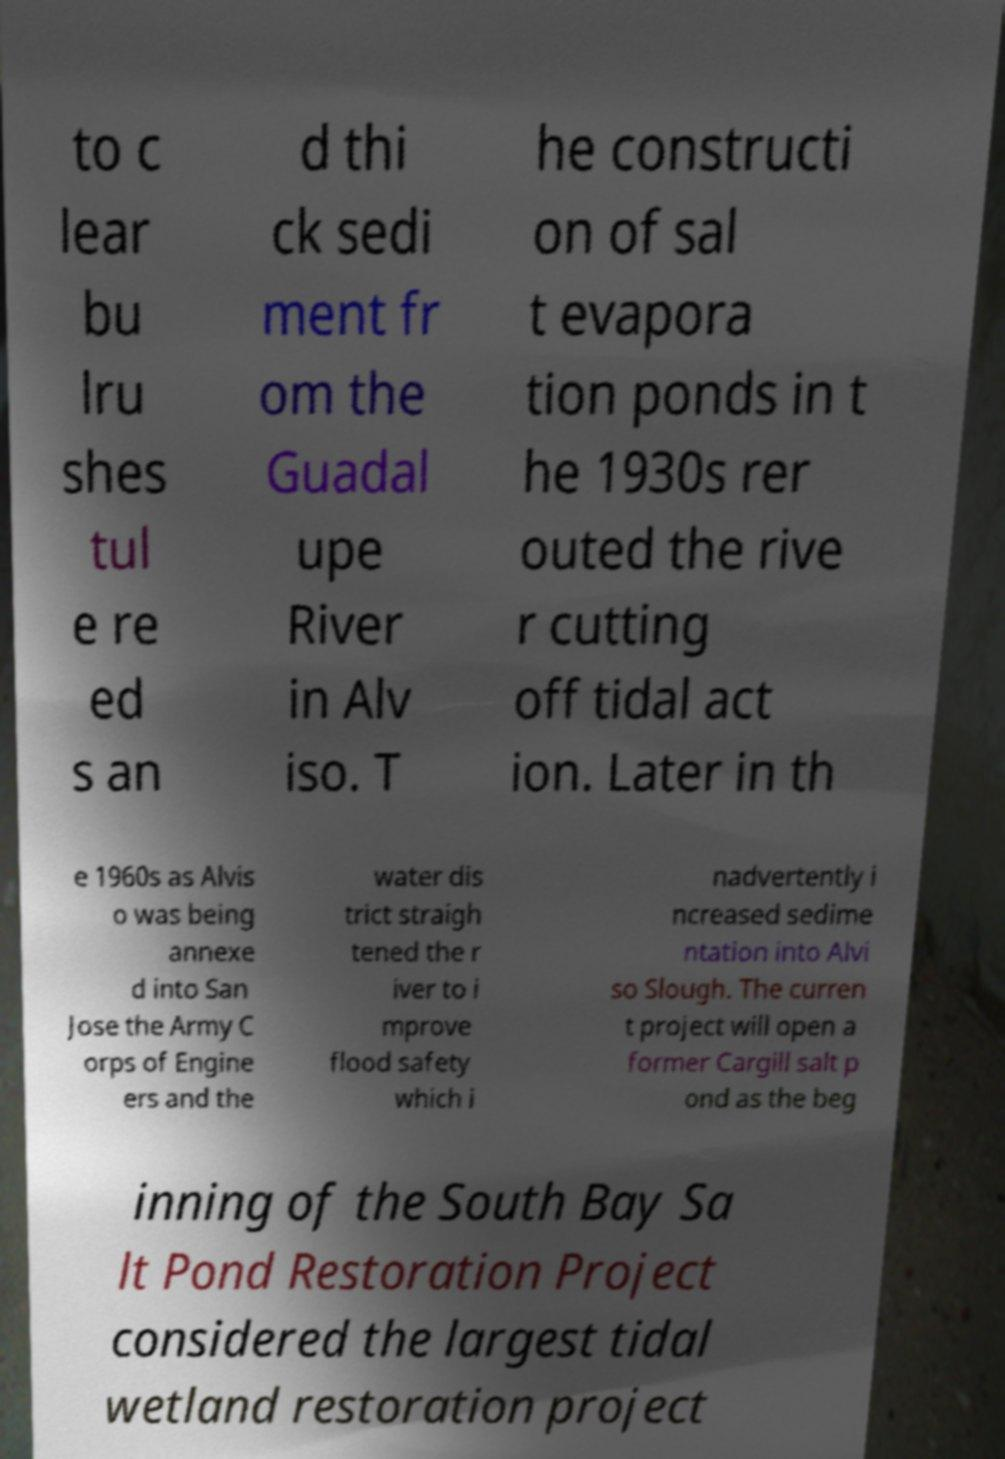What messages or text are displayed in this image? I need them in a readable, typed format. to c lear bu lru shes tul e re ed s an d thi ck sedi ment fr om the Guadal upe River in Alv iso. T he constructi on of sal t evapora tion ponds in t he 1930s rer outed the rive r cutting off tidal act ion. Later in th e 1960s as Alvis o was being annexe d into San Jose the Army C orps of Engine ers and the water dis trict straigh tened the r iver to i mprove flood safety which i nadvertently i ncreased sedime ntation into Alvi so Slough. The curren t project will open a former Cargill salt p ond as the beg inning of the South Bay Sa lt Pond Restoration Project considered the largest tidal wetland restoration project 